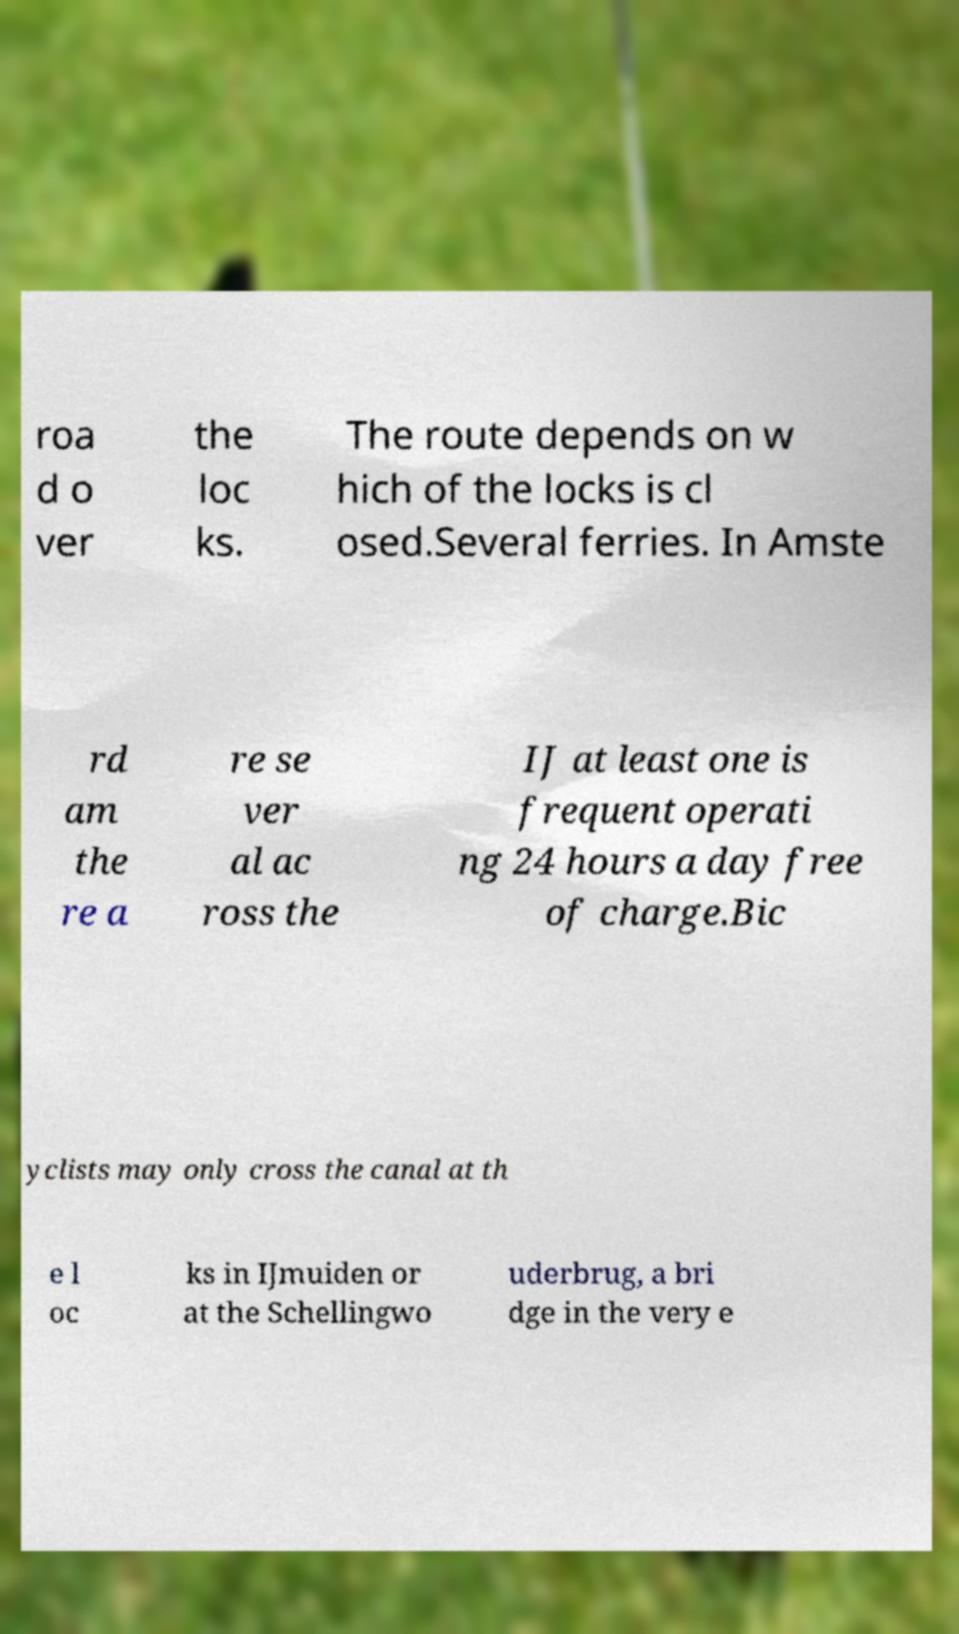Please identify and transcribe the text found in this image. roa d o ver the loc ks. The route depends on w hich of the locks is cl osed.Several ferries. In Amste rd am the re a re se ver al ac ross the IJ at least one is frequent operati ng 24 hours a day free of charge.Bic yclists may only cross the canal at th e l oc ks in IJmuiden or at the Schellingwo uderbrug, a bri dge in the very e 